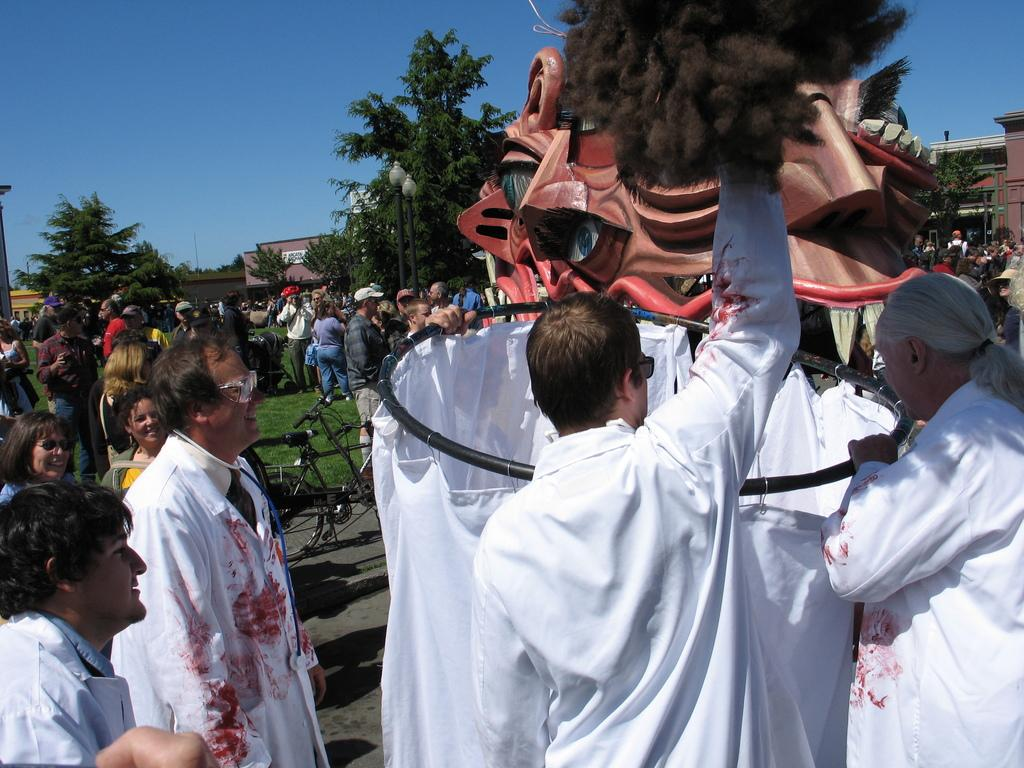Who or what can be seen in the image? There are people in the image. What is the subject of the depiction in the image? There is a depiction of a dinosaur in the image. What type of natural environment is visible in the background of the image? There are trees in the background of the image. What type of man-made structures can be seen in the background of the image? There are buildings in the background of the image. What type of grain is being polished by the people in the image? There is no grain or polishing activity present in the image; it features people and a depiction of a dinosaur. What is the wrist size of the dinosaur in the image? The image is a depiction of a dinosaur, and dinosaurs do not have wrists like humans. 